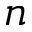Convert formula to latex. <formula><loc_0><loc_0><loc_500><loc_500>n</formula> 